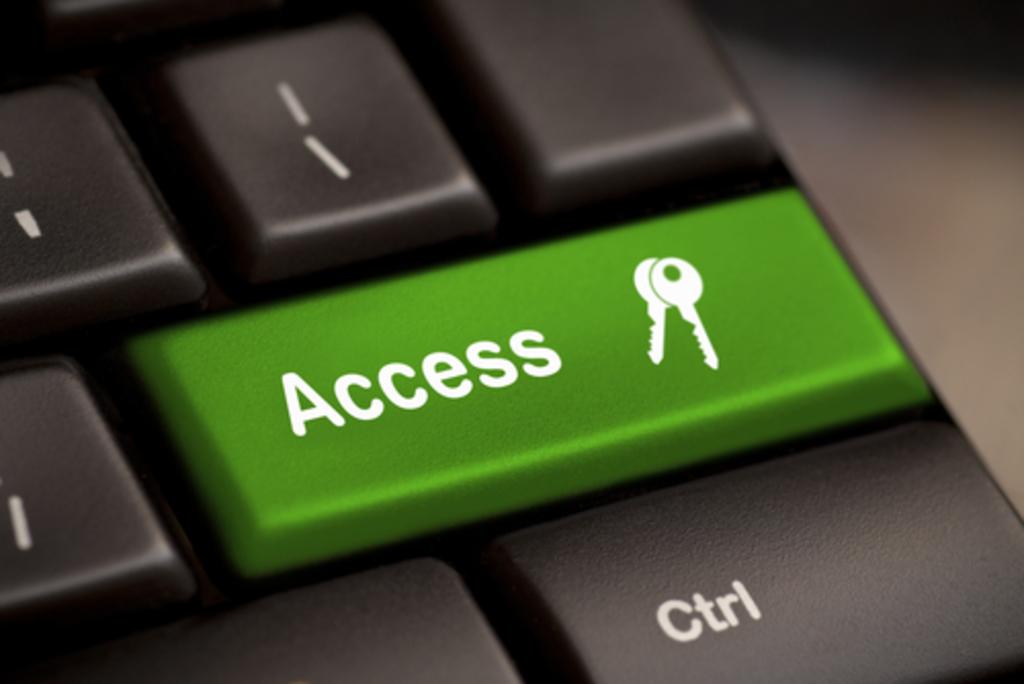What key is below access?
Give a very brief answer. Ctrl. 